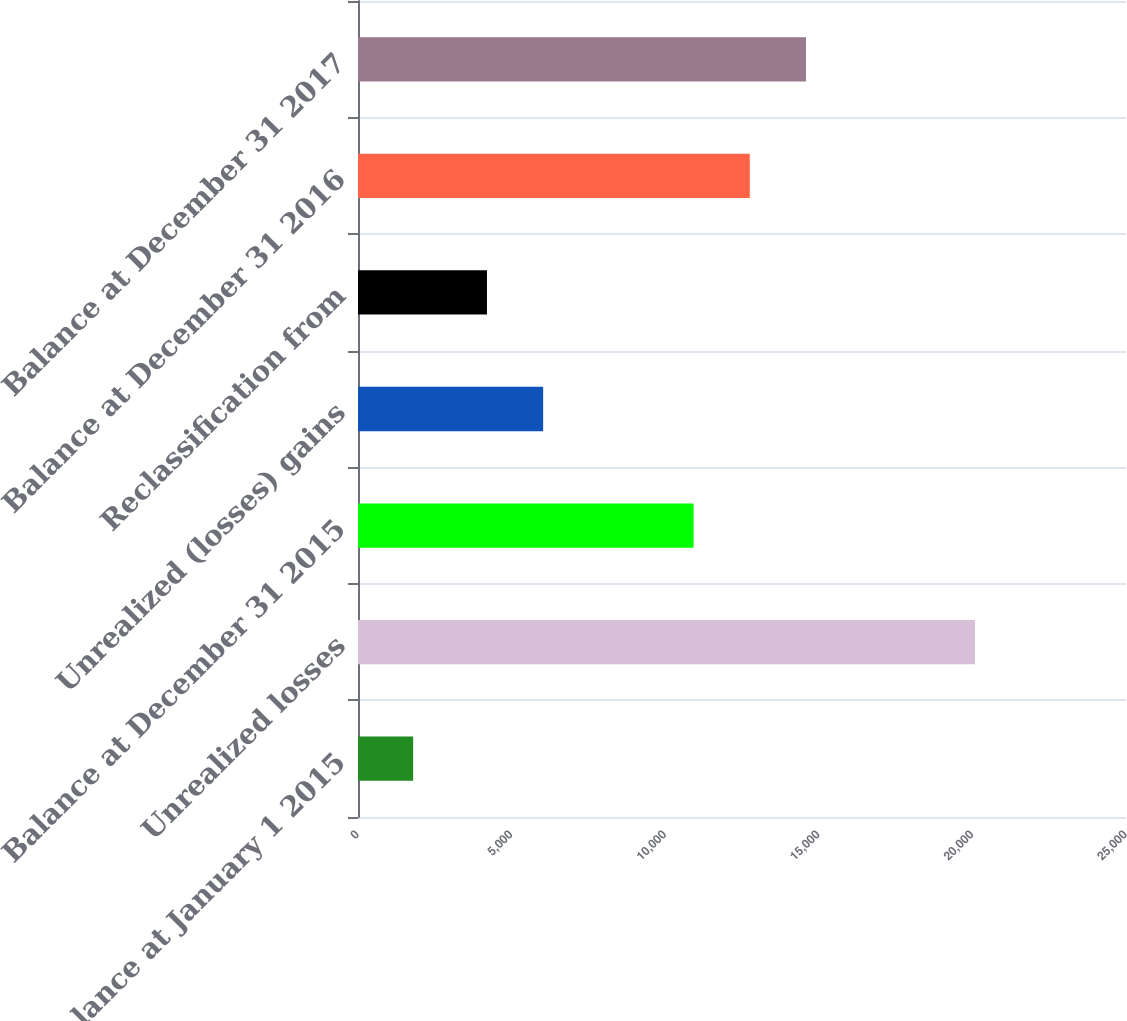Convert chart to OTSL. <chart><loc_0><loc_0><loc_500><loc_500><bar_chart><fcel>Balance at January 1 2015<fcel>Unrealized losses<fcel>Balance at December 31 2015<fcel>Unrealized (losses) gains<fcel>Reclassification from<fcel>Balance at December 31 2016<fcel>Balance at December 31 2017<nl><fcel>1795<fcel>20085<fcel>10925<fcel>6027<fcel>4198<fcel>12754<fcel>14583<nl></chart> 